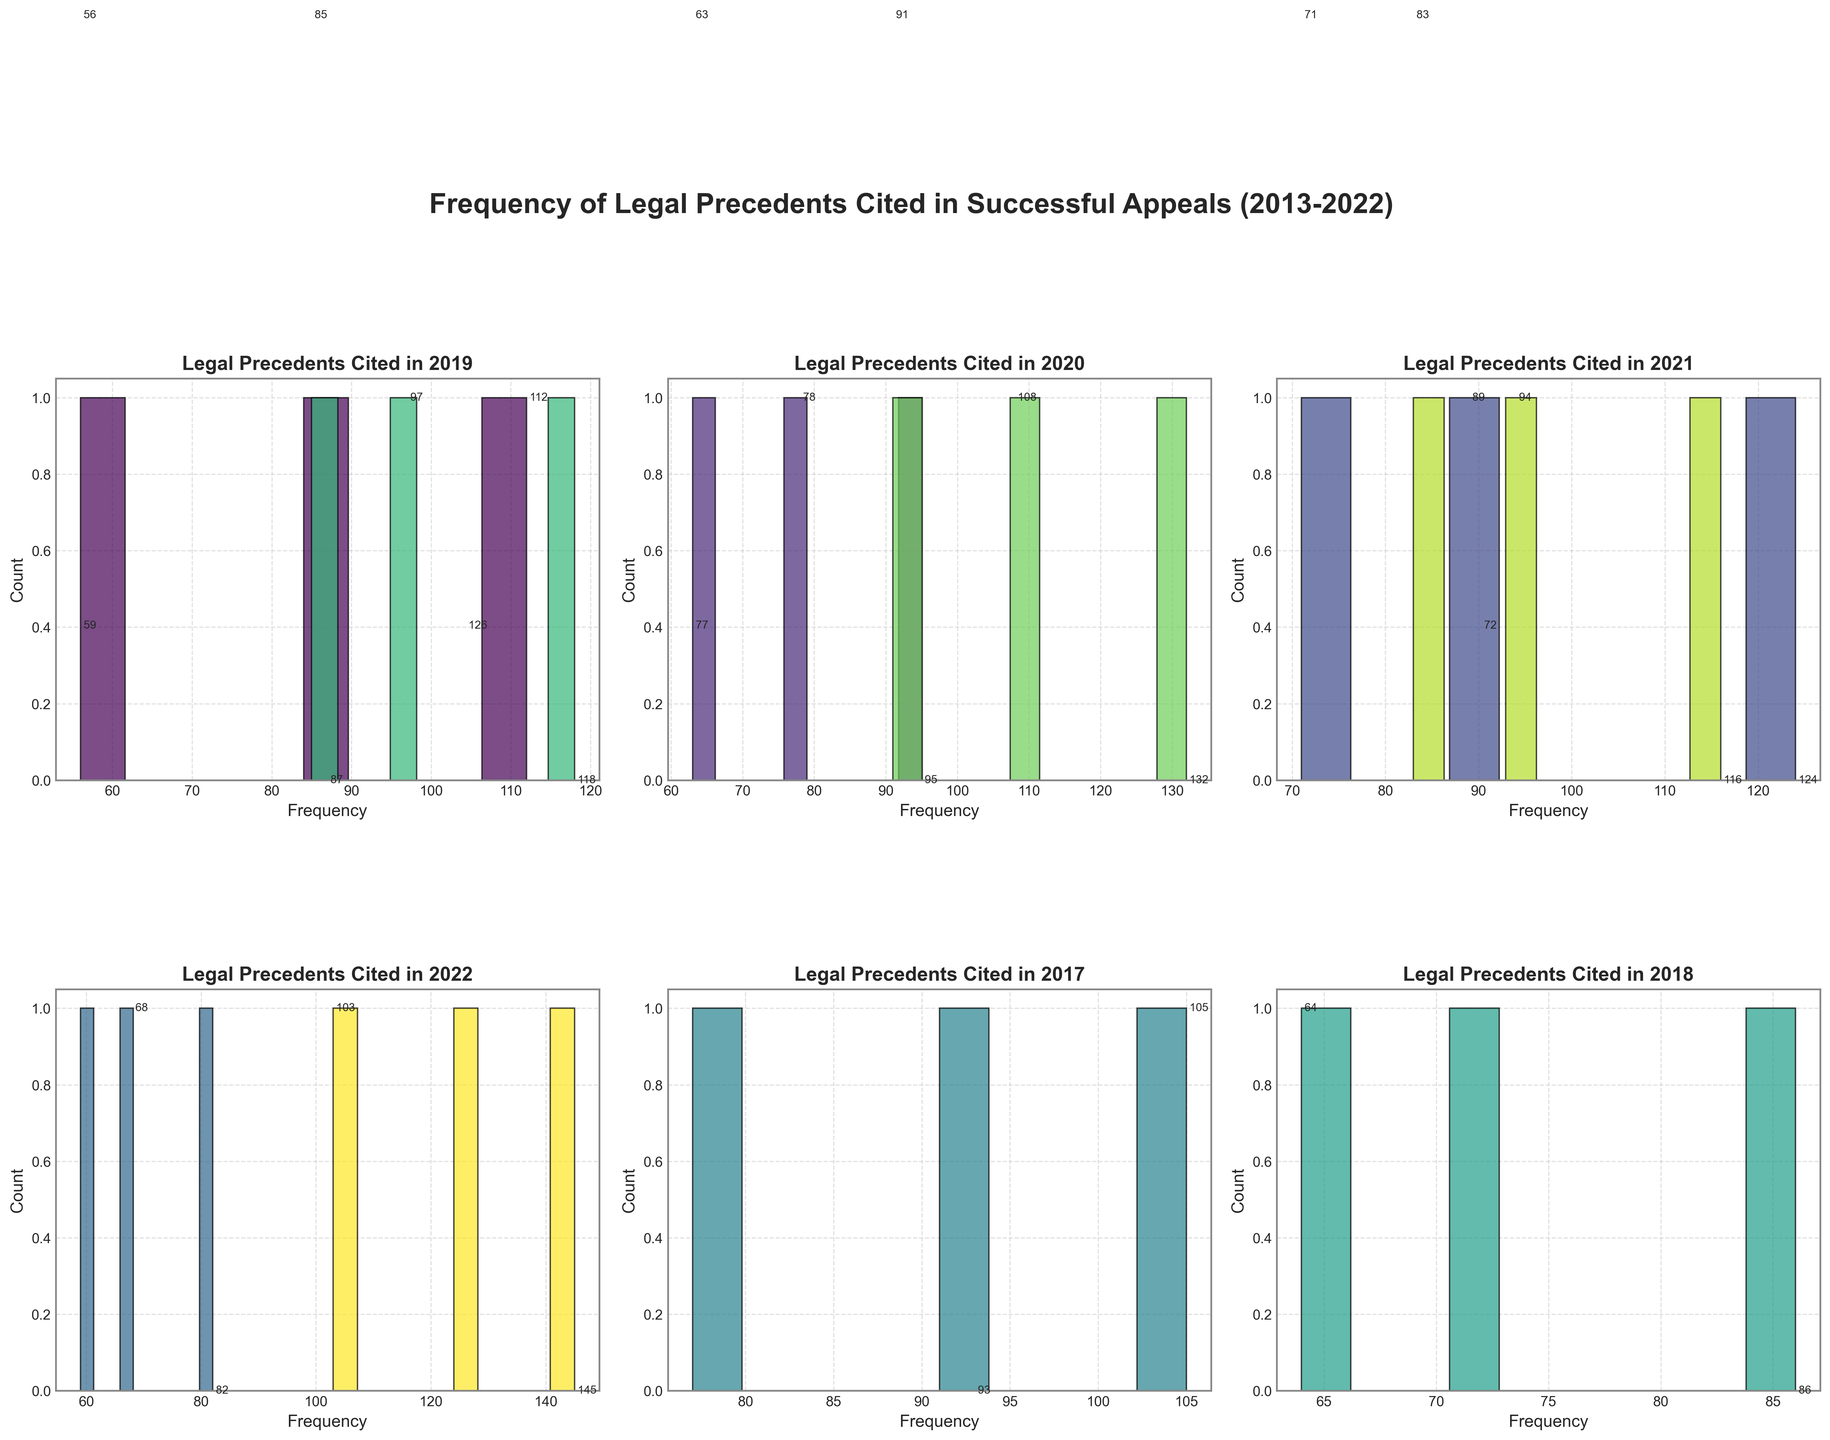What is the title of the figure? The title of a figure is usually located at the top of the plot and gives a brief description of what the figure represents. Here, the title is "Frequency of Legal Precedents Cited in Successful Appeals (2013-2022)".
Answer: Frequency of Legal Precedents Cited in Successful Appeals (2013-2022) How many subplots are in the figure? The figure description mentions 2 rows and 3 columns, making up a grid of 6 subplots.
Answer: 6 What does each subplot represent? Each subplot represents the frequency distribution of legal precedents cited in successful appeals for a specific year, as indicated by its title.
Answer: Frequency distribution for a specific year Which year has the highest-cited precedent, and what is its frequency? By checking the frequency annotations in each subplot, the year 2022 has the highest-cited precedent with "Dobbs v. Jackson Women's Health Organization" cited 145 times.
Answer: 2022, 145 What is the trend in the frequency range of cited precedents from 2013 to 2022? By analyzing each subplot sequentially, one can see an increasing trend in the range of citation frequencies, with the 2022 subplot displaying the widest range and highest values.
Answer: Increasing trend Which subplot has the most evenly distributed frequencies? The 2015 subplot has citations ranging fairly evenly around the 80-90 mark without major peaks or outliers, indicating a more even distribution.
Answer: 2015 How does the citation frequency in 2019 compare to 2018? By examining the histograms of these two years, 2019 has higher citation frequencies overall compared to 2018, with the peak frequencies also being higher.
Answer: 2019 has higher frequencies What is the common annual frequency range across most subplots? Observing the frequency intervals across all subplots, most years have a common frequency range of 60-120 citations.
Answer: 60-120 citations Which year features the largest number of cited precedents above 100? The 2022 subplot has multiple precedents cited above 100 times, including "Dobbs v. Jackson Women's Health Organization", "Kennedy v. Bremerton School District", and "New York State Rifle & Pistol Association v. Bruen".
Answer: 2022 How does the frequency of "Miranda v. Arizona" in 2013 compare to that of "Obergefell v. Hodges" in 2015? "Miranda v. Arizona" has a frequency of 112 in 2013, whereas "Obergefell v. Hodges" has a frequency of 124 in 2015, meaning "Obergefell v. Hodges" is cited more frequently.
Answer: Obergefell v. Hodges is cited more frequently 